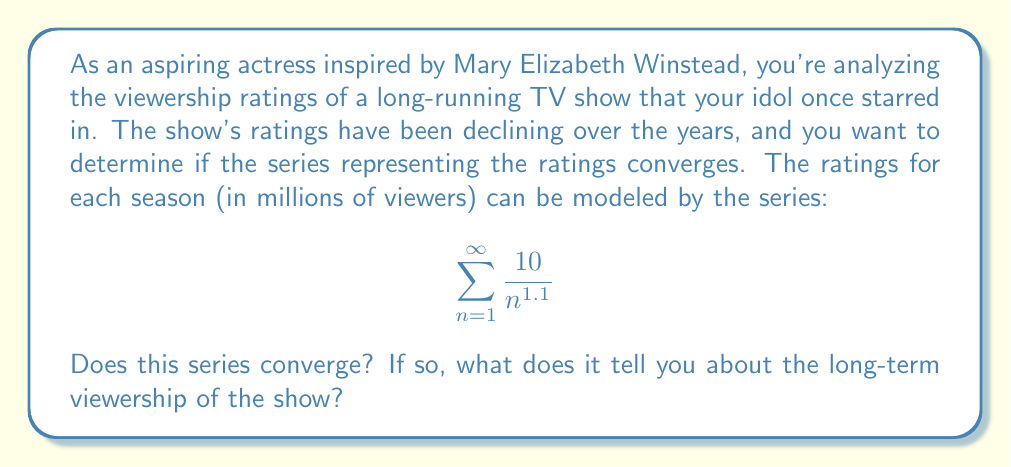Show me your answer to this math problem. To determine if this series converges, we can use the p-series test:

1) The general form of a p-series is:
   $$ \sum_{n=1}^{\infty} \frac{1}{n^p} $$

2) Our series can be rewritten as:
   $$ 10 \sum_{n=1}^{\infty} \frac{1}{n^{1.1}} $$

3) In this case, $p = 1.1$

4) The p-series convergence theorem states:
   - If $p > 1$, the series converges
   - If $p \leq 1$, the series diverges

5) Since $1.1 > 1$, this series converges.

6) The convergence of this series means that the sum of all terms approaches a finite value as $n$ approaches infinity.

7) In the context of TV ratings, this implies that:
   - The viewership will continue to decline but at a decreasing rate.
   - The total cumulative viewership over all seasons will be finite.
   - The show will eventually reach a point where additional seasons contribute negligibly to the total viewership.

8) While we can't determine the exact value of convergence without additional calculations, we know it exists and is finite.
Answer: The series converges. This indicates that the long-term viewership of the show will stabilize at a low level, with each new season contributing less and less to the total viewership. 